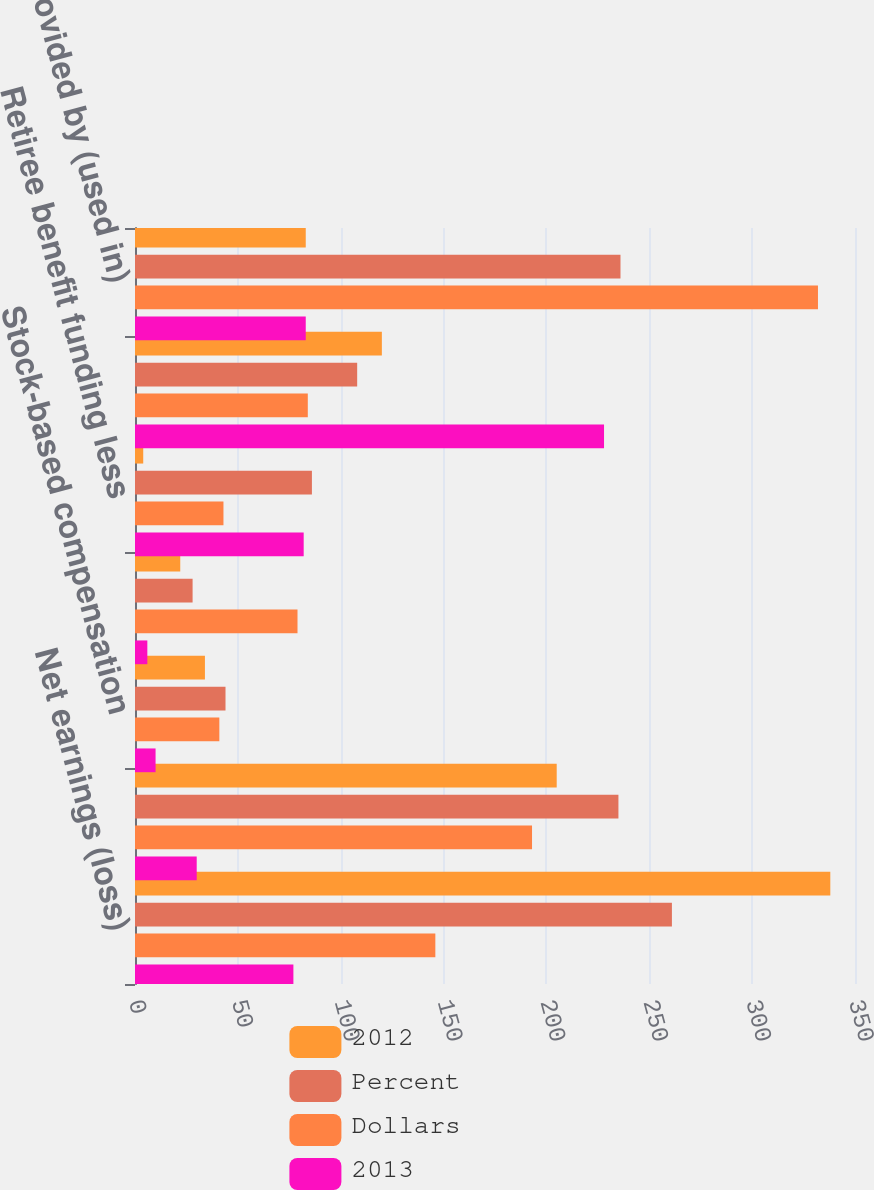Convert chart. <chart><loc_0><loc_0><loc_500><loc_500><stacked_bar_chart><ecel><fcel>Net earnings (loss)<fcel>Depreciation and amortization<fcel>Stock-based compensation<fcel>Deferred income taxes<fcel>Retiree benefit funding less<fcel>Trade working capital decrease<fcel>Net cash provided by (used in)<nl><fcel>2012<fcel>338<fcel>205<fcel>34<fcel>22<fcel>4<fcel>120<fcel>83<nl><fcel>Percent<fcel>261<fcel>235<fcel>44<fcel>28<fcel>86<fcel>108<fcel>236<nl><fcel>Dollars<fcel>146<fcel>193<fcel>41<fcel>79<fcel>43<fcel>84<fcel>332<nl><fcel>2013<fcel>77<fcel>30<fcel>10<fcel>6<fcel>82<fcel>228<fcel>83<nl></chart> 